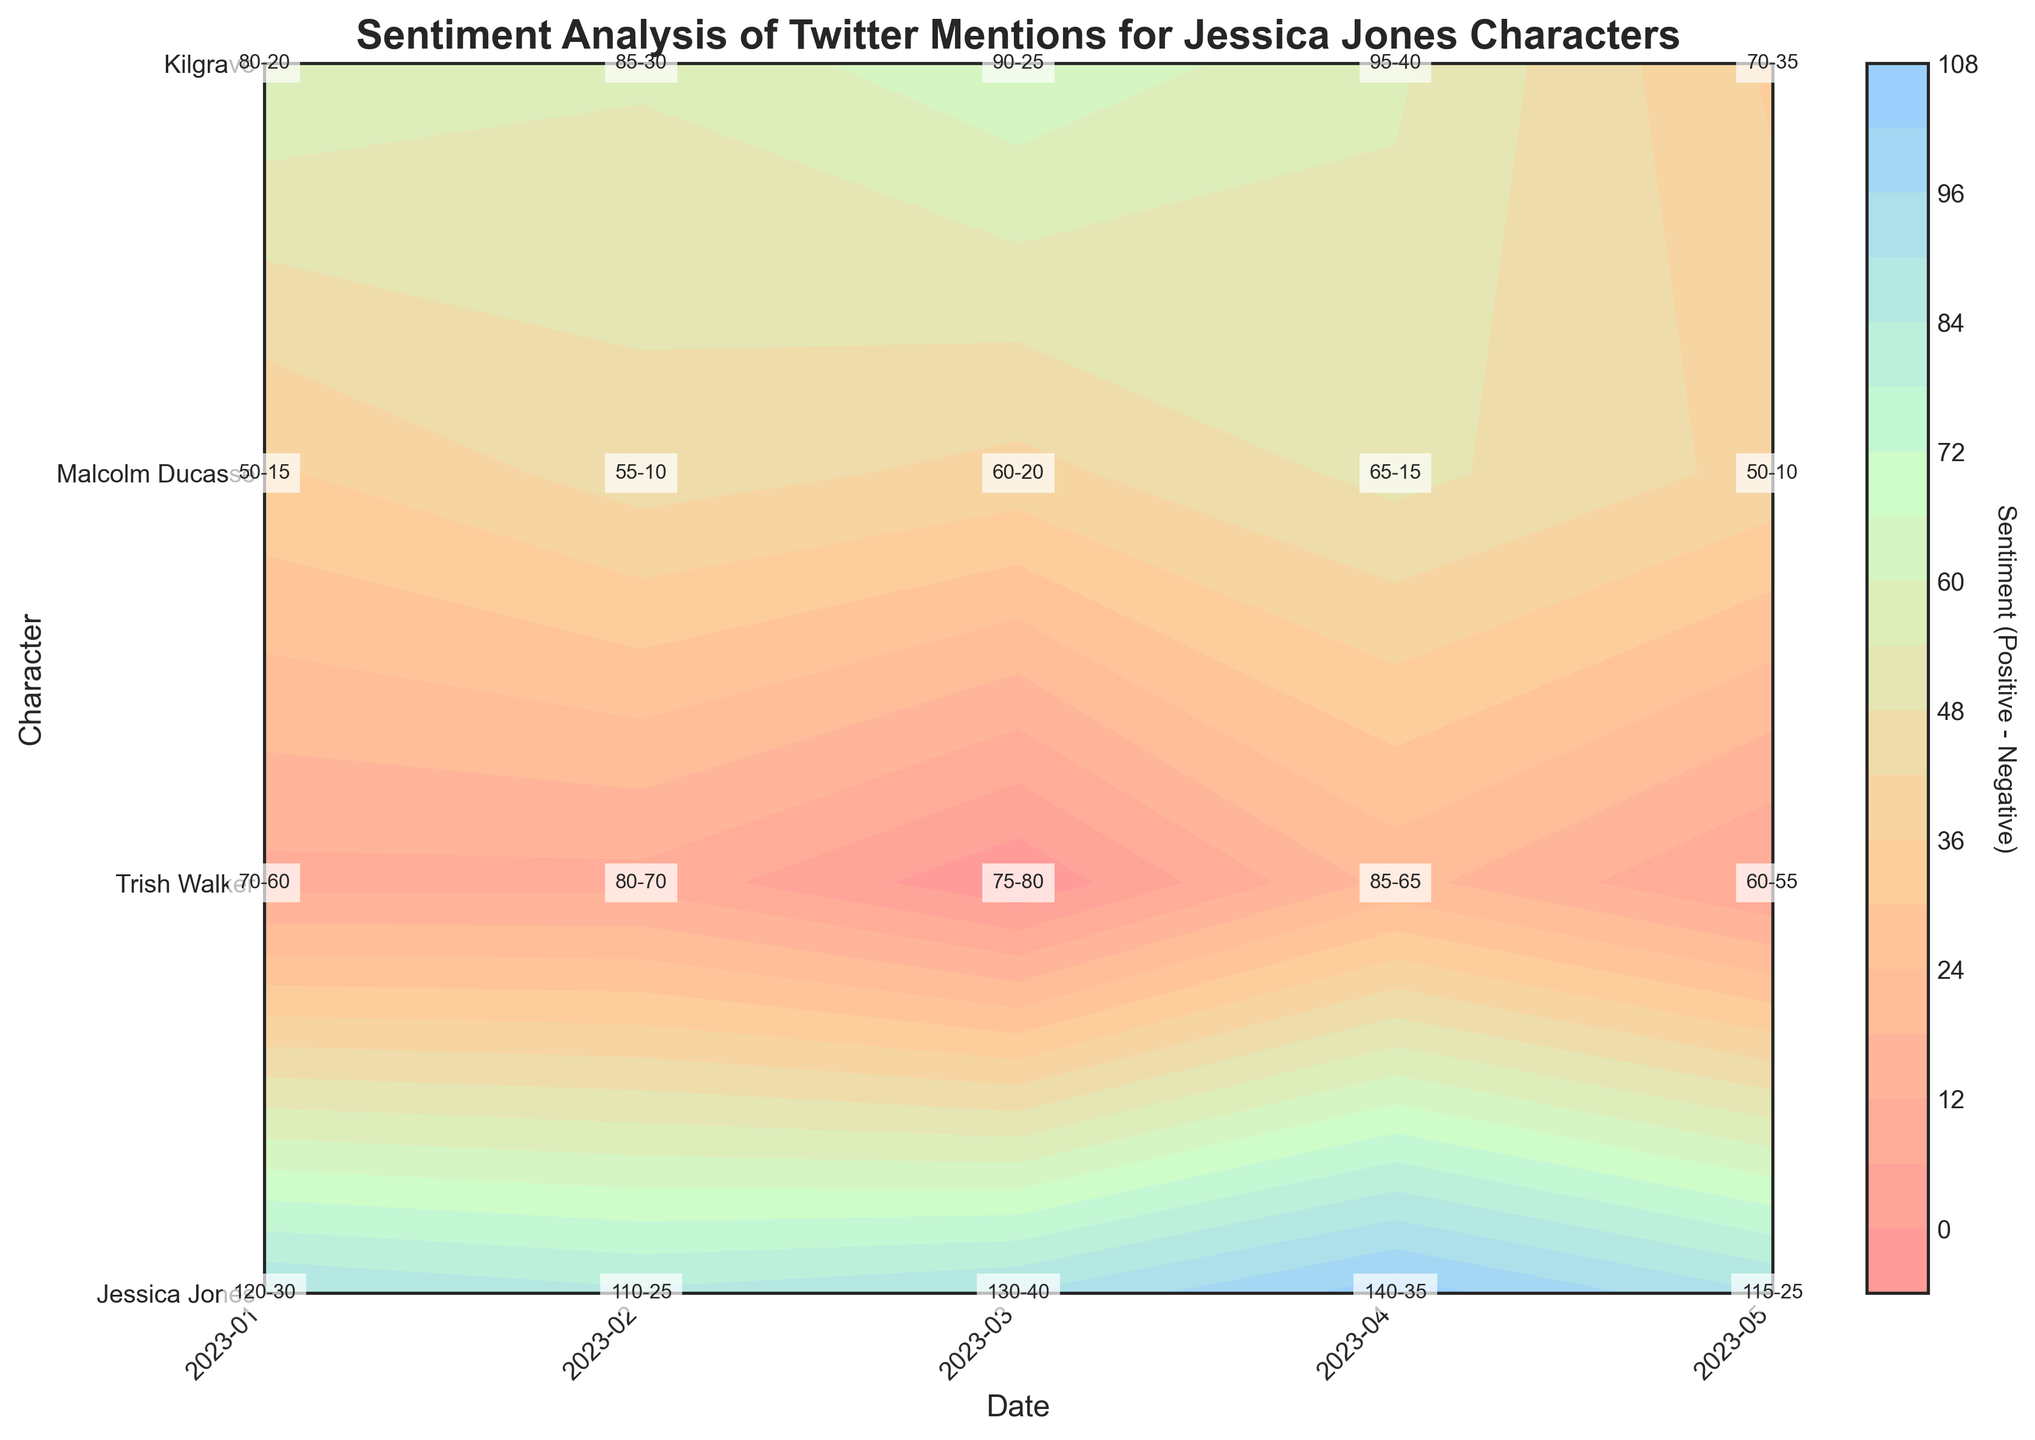What's the title of the plot? The title of the plot is displayed at the top and it reads "Sentiment Analysis of Twitter Mentions for Jessica Jones Characters".
Answer: Sentiment Analysis of Twitter Mentions for Jessica Jones Characters Which character received the highest positive mentions in April 2023? By examining the contour plot in April 2023, we see that "Jessica Jones" has the highest positive mentions with a value of 140.
Answer: Jessica Jones How did the sentiment for Kilgrave change from January to February 2023? The sentiment is measured by the difference between positive and negative mentions. In January 2023, Kilgrave had 70 positive and 60 negative mentions (70 - 60 = 10). In February 2023, he had 80 positive and 70 negative mentions (80 - 70 = 10). The sentiment score remained the same at 10.
Answer: No change Which month shows the highest negative sentiment value for any character? By checking each month's highest negative mention value, we see March 2023 has the highest negative sentiment value for Kilgrave with 80 negative mentions.
Answer: March 2023 What character and date combination has the highest difference in positive and negative mentions? For each character and date combination, we subtract the negative mentions from the positive mentions. "Jessica Jones" on April 2023 shows the highest difference (140 positive - 35 negative = 105).
Answer: Jessica Jones, April 2023 Compare the sentiment differences for Malcolm Ducasse in January and May 2023. In January 2023, Malcolm Ducasse had 50 positive and 15 negative mentions (50 - 15 = 35). In May 2023, he had 50 positive and 10 negative mentions (50 - 10 = 40). Comparing these, his sentiment in May 2023 was higher.
Answer: May 2023 Which two characters had the closest sentiment scores in February 2023? The sentiment score for each character is calculated by subtracting negative mentions from positive mentions. In February 2023, "Trish Walker" had 85 positive and 30 negative mentions (55 sentiment) and "Malcolm Ducasse" had 55 positive and 10 negative mentions (45 sentiment). These scores are closest to each other.
Answer: Trish Walker and Malcolm Ducasse What is the average sentiment for Jessica Jones over the five months? Calculate the sentiment for Jessica Jones each month: Jan (120-30=90), Feb (110-25=85), Mar (130-40=90), Apr (140-35=105), May (115-25=90). Sum these sentiments and then divide by 5. (90 + 85 + 90 + 105 + 90) / 5 = 92
Answer: 92 What's the general trend of positive mentions for Jessica Jones over the period? Referring to the data points for Jessica Jones, we see positive mentions start at 120 in January, drop to 110 in February, then increase through March (130) and April (140), before decreasing back to 115 in May.
Answer: Mixed: Initial drop, then rise, followed by a slight drop In which month does Malcolm Ducasse exhibit his lowest neutral sentiment? Examining the neutral sentiment from the data, Malcolm Ducasse has the lowest neutral mentions (35) in January 2023.
Answer: January 2023 